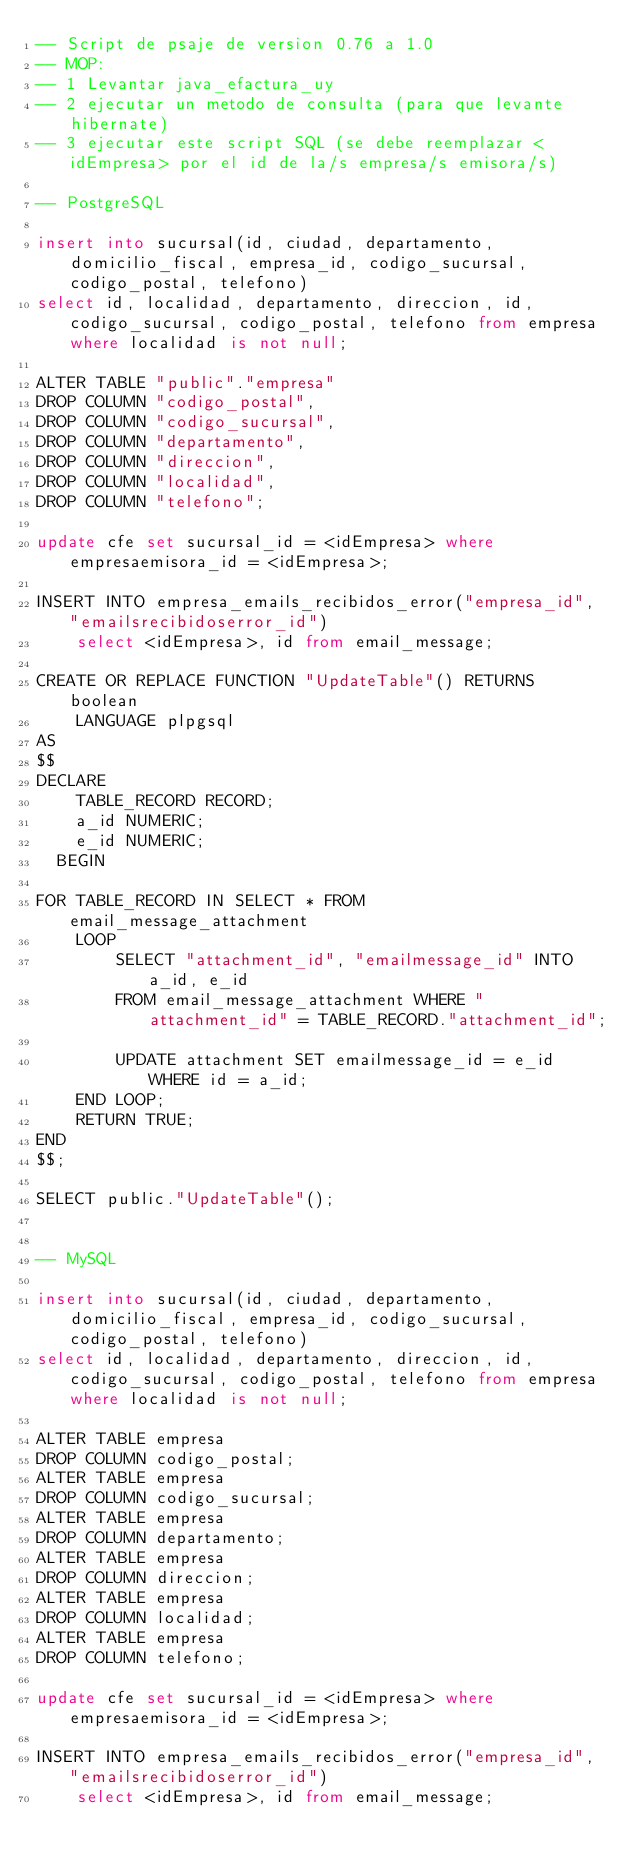Convert code to text. <code><loc_0><loc_0><loc_500><loc_500><_SQL_>-- Script de psaje de version 0.76 a 1.0
-- MOP: 
-- 1 Levantar java_efactura_uy
-- 2 ejecutar un metodo de consulta (para que levante hibernate)
-- 3 ejecutar este script SQL (se debe reemplazar <idEmpresa> por el id de la/s empresa/s emisora/s)

-- PostgreSQL

insert into sucursal(id, ciudad, departamento, domicilio_fiscal, empresa_id, codigo_sucursal, codigo_postal, telefono)
select id, localidad, departamento, direccion, id, codigo_sucursal, codigo_postal, telefono from empresa where localidad is not null;

ALTER TABLE "public"."empresa"
DROP COLUMN "codigo_postal",
DROP COLUMN "codigo_sucursal",
DROP COLUMN "departamento",
DROP COLUMN "direccion",
DROP COLUMN "localidad",
DROP COLUMN "telefono";

update cfe set sucursal_id = <idEmpresa> where empresaemisora_id = <idEmpresa>;

INSERT INTO empresa_emails_recibidos_error("empresa_id", "emailsrecibidoserror_id") 
	select <idEmpresa>, id from email_message;

CREATE OR REPLACE FUNCTION "UpdateTable"() RETURNS boolean
    LANGUAGE plpgsql
AS
$$
DECLARE
    TABLE_RECORD RECORD;
    a_id NUMERIC;
    e_id NUMERIC;
  BEGIN
    
FOR TABLE_RECORD IN SELECT * FROM email_message_attachment
    LOOP
        SELECT "attachment_id", "emailmessage_id" INTO a_id, e_id
        FROM email_message_attachment WHERE "attachment_id" = TABLE_RECORD."attachment_id";

        UPDATE attachment SET emailmessage_id = e_id WHERE id = a_id; 
    END LOOP;
    RETURN TRUE;
END
$$;

SELECT public."UpdateTable"();


-- MySQL

insert into sucursal(id, ciudad, departamento, domicilio_fiscal, empresa_id, codigo_sucursal, codigo_postal, telefono)
select id, localidad, departamento, direccion, id, codigo_sucursal, codigo_postal, telefono from empresa where localidad is not null;

ALTER TABLE empresa
DROP COLUMN codigo_postal;
ALTER TABLE empresa
DROP COLUMN codigo_sucursal;
ALTER TABLE empresa
DROP COLUMN departamento;
ALTER TABLE empresa
DROP COLUMN direccion;
ALTER TABLE empresa
DROP COLUMN localidad;
ALTER TABLE empresa
DROP COLUMN telefono;

update cfe set sucursal_id = <idEmpresa> where empresaemisora_id = <idEmpresa>;

INSERT INTO empresa_emails_recibidos_error("empresa_id", "emailsrecibidoserror_id") 
	select <idEmpresa>, id from email_message;

</code> 